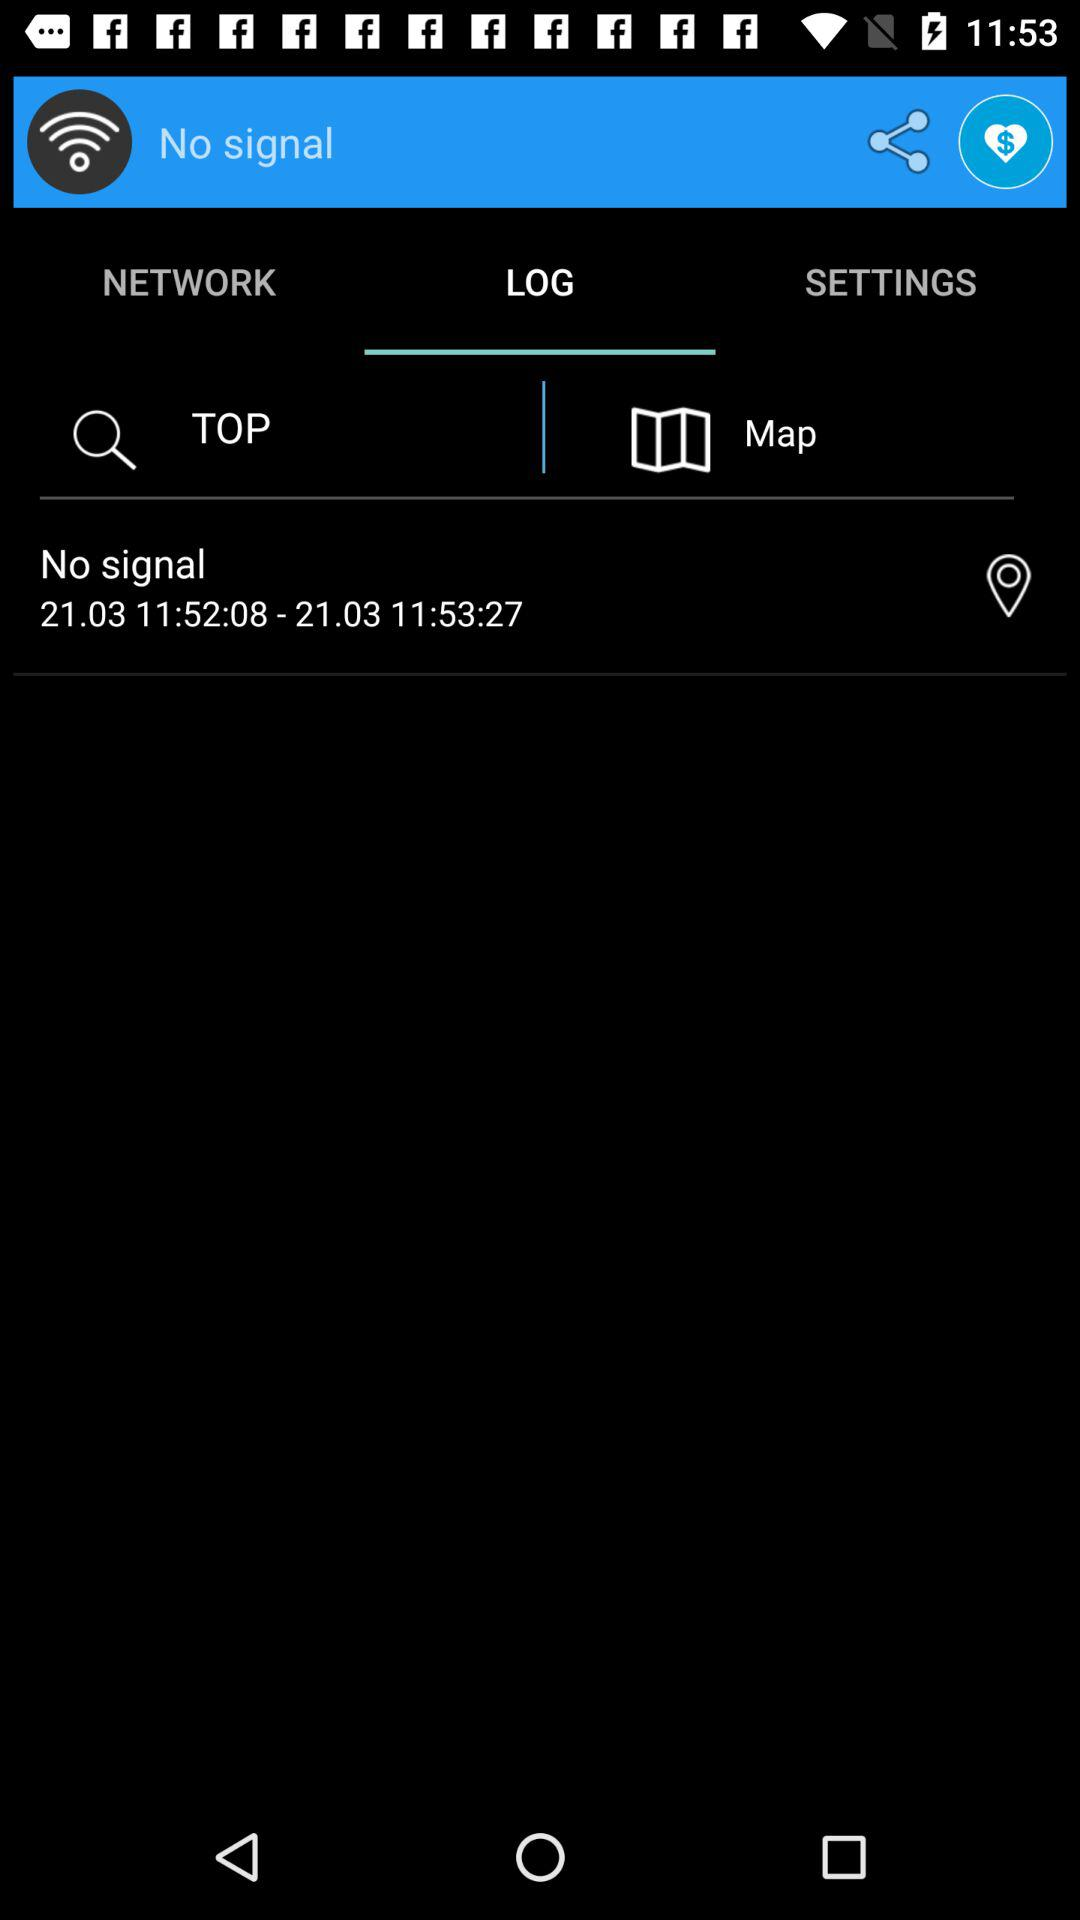Which tab is selected? The selected tab is "LOG". 